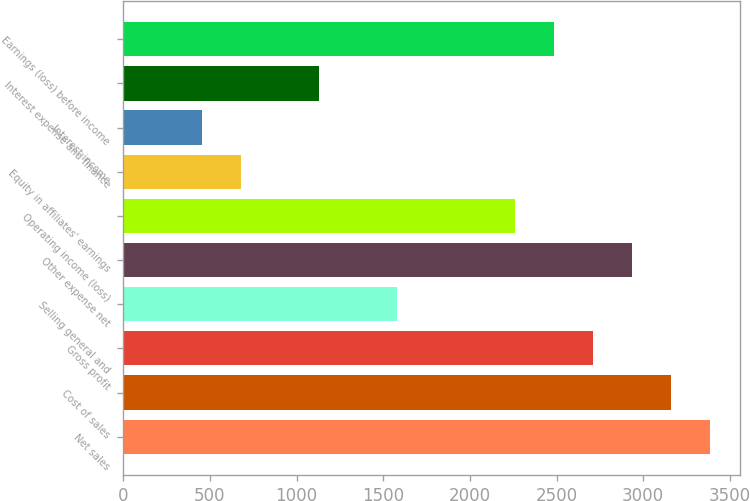Convert chart to OTSL. <chart><loc_0><loc_0><loc_500><loc_500><bar_chart><fcel>Net sales<fcel>Cost of sales<fcel>Gross profit<fcel>Selling general and<fcel>Other expense net<fcel>Operating income (loss)<fcel>Equity in affiliates' earnings<fcel>Interest income<fcel>Interest expense and finance<fcel>Earnings (loss) before income<nl><fcel>3387.79<fcel>3162.03<fcel>2710.51<fcel>1581.71<fcel>2936.27<fcel>2258.99<fcel>678.67<fcel>452.91<fcel>1130.19<fcel>2484.75<nl></chart> 